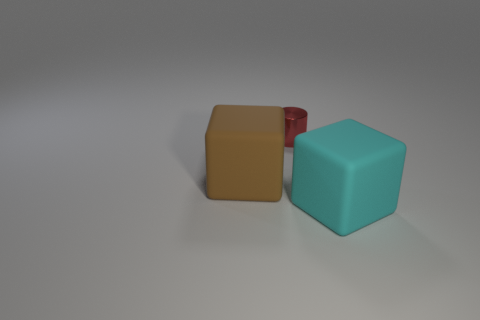Add 1 small shiny objects. How many objects exist? 4 Subtract all cyan cubes. How many cubes are left? 1 Subtract all brown cylinders. How many brown cubes are left? 1 Subtract all red cubes. Subtract all red cylinders. How many cubes are left? 2 Subtract all cylinders. How many objects are left? 2 Subtract 2 blocks. How many blocks are left? 0 Subtract 0 yellow balls. How many objects are left? 3 Subtract all tiny matte things. Subtract all large blocks. How many objects are left? 1 Add 2 big cyan matte blocks. How many big cyan matte blocks are left? 3 Add 1 large blocks. How many large blocks exist? 3 